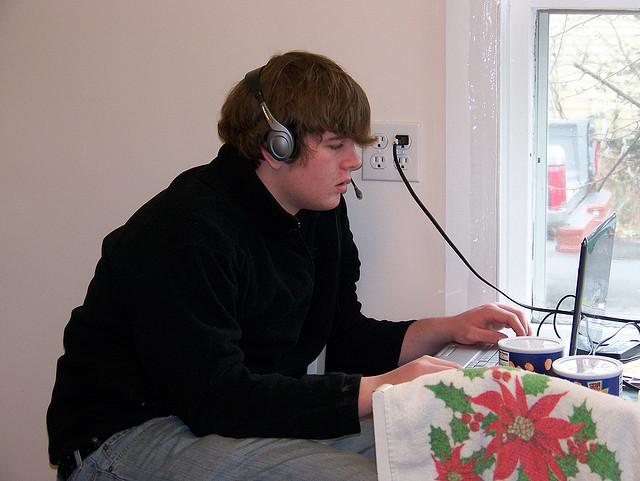What type of flower is on the cloth?
Answer briefly. Poinsettia. What is on his ears?
Answer briefly. Headphones. Do the containers have lids on?
Concise answer only. Yes. 